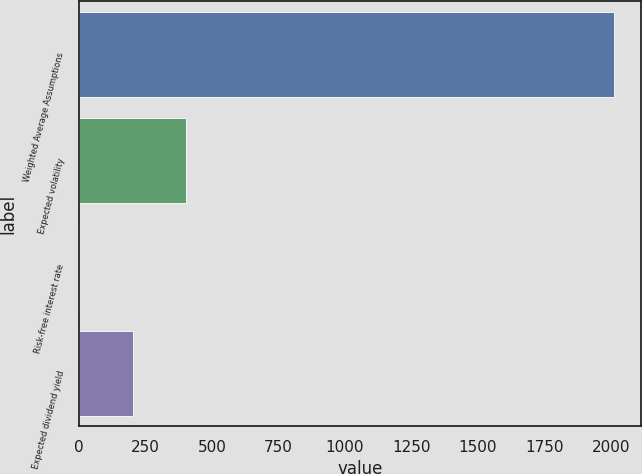Convert chart to OTSL. <chart><loc_0><loc_0><loc_500><loc_500><bar_chart><fcel>Weighted Average Assumptions<fcel>Expected volatility<fcel>Risk-free interest rate<fcel>Expected dividend yield<nl><fcel>2013<fcel>403.51<fcel>1.13<fcel>202.32<nl></chart> 